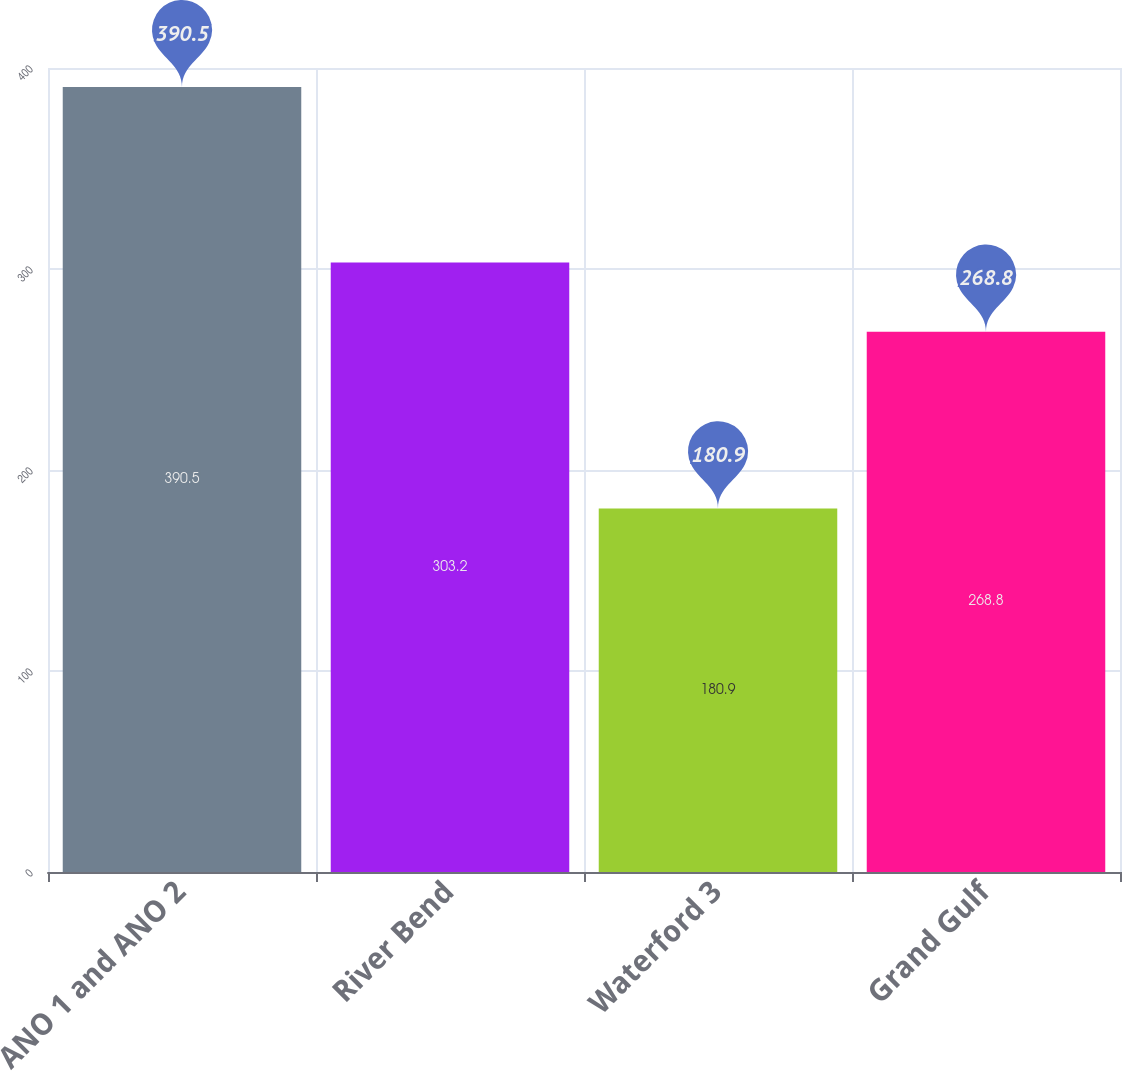<chart> <loc_0><loc_0><loc_500><loc_500><bar_chart><fcel>ANO 1 and ANO 2<fcel>River Bend<fcel>Waterford 3<fcel>Grand Gulf<nl><fcel>390.5<fcel>303.2<fcel>180.9<fcel>268.8<nl></chart> 